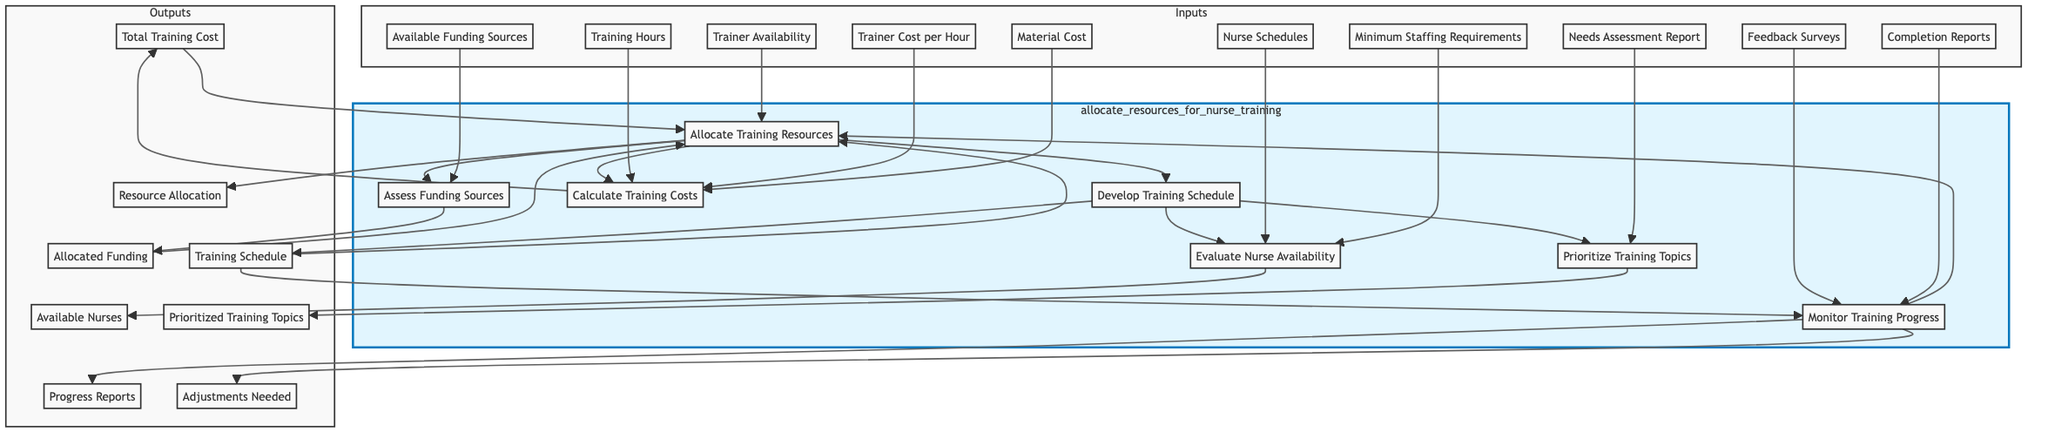What is the first step in allocating resources for nurse training programs? The first step identified in the flowchart is "Calculate Training Costs," which assesses the total cost required for the nurse training programs.
Answer: Calculate Training Costs How many input sources are there for the "Allocate Training Resources" process? The "Allocate Training Resources" process has four inputs: trainer availability, total training cost, allocated funding, and training schedule.
Answer: Four What is the output of the "Assess Funding Sources"? The output of the "Assess Funding Sources" process is "Allocated Funding," which indicates the funding available for the training programs.
Answer: Allocated Funding What are the two processes that directly lead to "Allocate Training Resources"? The two processes that lead to "Allocate Training Resources" are "Develop Training Schedule" and "Evaluate Nurse Availability."
Answer: Develop Training Schedule and Evaluate Nurse Availability How do the outputs of "Prioritize Training Topics" and "Evaluate Nurse Availability" contribute to the overall training program? The outputs from "Prioritize Training Topics," which is prioritized training topics, and "Evaluate Nurse Availability," which yields available nurses, are crucial inputs for the "Develop Training Schedule" phase, combining topic priorities with available personnel for effective scheduling.
Answer: They provide inputs for Develop Training Schedule What is the final output of the entire process depicted in the flowchart? The final output of the diagram is "Progress Reports and Adjustments Needed," which results from ongoing monitoring after the training sessions.
Answer: Progress Reports and Adjustments Needed Which process assesses the available funding sources? The process that assesses available funding sources is "Assess Funding Sources."
Answer: Assess Funding Sources What is the relationship between "Calculate Training Costs" and its outputs? "Calculate Training Costs" processes inputs to generate the output "Total Training Cost," indicating the financial requirement for the training program.
Answer: Total Training Cost Identify an input necessary for "Develop Training Schedule." An input necessary for "Develop Training Schedule" is "Available Nurses."
Answer: Available Nurses 